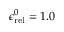Convert formula to latex. <formula><loc_0><loc_0><loc_500><loc_500>\epsilon _ { r e l } ^ { 0 } = 1 . 0</formula> 